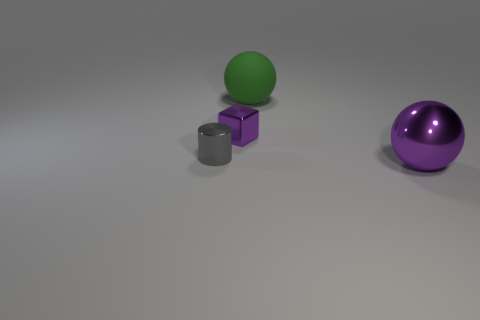How many other big things have the same shape as the gray metallic object?
Your answer should be compact. 0. There is a tiny purple object that is the same material as the small cylinder; what shape is it?
Your answer should be compact. Cube. What is the large sphere in front of the big thing behind the purple metal thing that is behind the tiny gray metallic cylinder made of?
Give a very brief answer. Metal. Is the size of the purple cube the same as the metallic object on the right side of the rubber ball?
Provide a succinct answer. No. There is another big green thing that is the same shape as the big metallic object; what is its material?
Ensure brevity in your answer.  Rubber. How big is the green sphere behind the purple metal object on the right side of the large object that is on the left side of the big purple object?
Your answer should be compact. Large. Is the gray thing the same size as the rubber object?
Your answer should be compact. No. Is the number of large things the same as the number of big blue objects?
Give a very brief answer. No. There is a large ball that is on the left side of the purple metal object that is in front of the tiny purple metal thing; what is its material?
Your answer should be very brief. Rubber. Is the shape of the metallic thing that is on the left side of the tiny purple metal thing the same as the large thing behind the large purple metallic sphere?
Your response must be concise. No. 